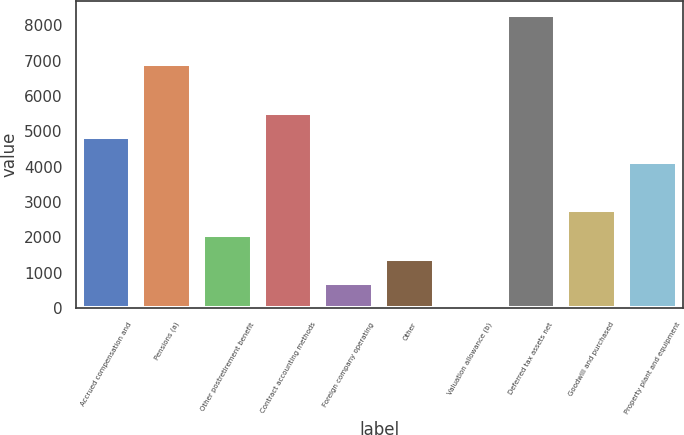Convert chart. <chart><loc_0><loc_0><loc_500><loc_500><bar_chart><fcel>Accrued compensation and<fcel>Pensions (a)<fcel>Other postretirement benefit<fcel>Contract accounting methods<fcel>Foreign company operating<fcel>Other<fcel>Valuation allowance (b)<fcel>Deferred tax assets net<fcel>Goodwill and purchased<fcel>Property plant and equipment<nl><fcel>4836.2<fcel>6905<fcel>2077.8<fcel>5525.8<fcel>698.6<fcel>1388.2<fcel>9<fcel>8284.2<fcel>2767.4<fcel>4146.6<nl></chart> 